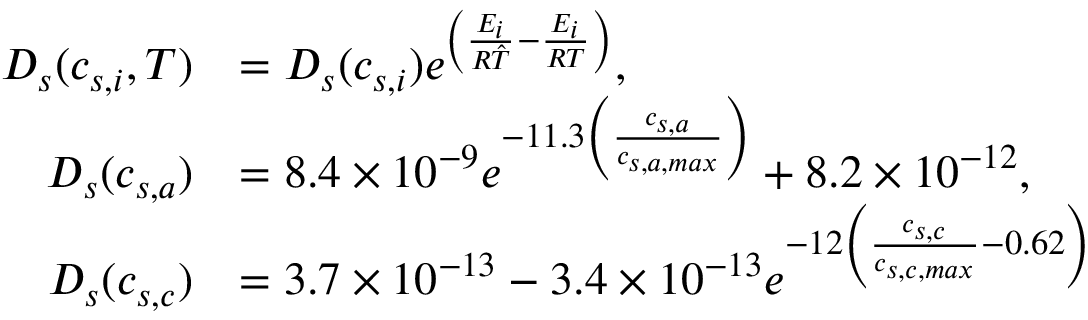Convert formula to latex. <formula><loc_0><loc_0><loc_500><loc_500>\begin{array} { r l } { D _ { s } ( c _ { s , i } , T ) } & { = D _ { s } ( c _ { s , i } ) e ^ { \left ( \frac { E _ { i } } { R \hat { T } } - \frac { E _ { i } } { R T } \right ) } , } \\ { D _ { s } ( c _ { s , a } ) } & { = 8 . 4 \times 1 0 ^ { - 9 } e ^ { - 1 1 . 3 \left ( \frac { c _ { s , a } } { c _ { s , a , \max } } \right ) } + 8 . 2 \times 1 0 ^ { - 1 2 } , } \\ { D _ { s } ( c _ { s , c } ) } & { = 3 . 7 \times 1 0 ^ { - 1 3 } - 3 . 4 \times 1 0 ^ { - 1 3 } e ^ { - 1 2 \left ( \frac { c _ { s , c } } { c _ { s , c , \max } } - 0 . 6 2 \right ) } } \end{array}</formula> 